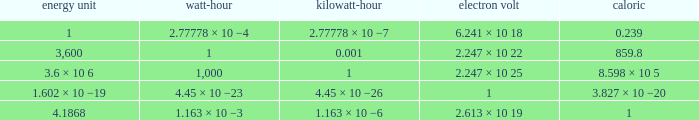Give me the full table as a dictionary. {'header': ['energy unit', 'watt-hour', 'kilowatt-hour', 'electron volt', 'caloric'], 'rows': [['1', '2.77778 × 10 −4', '2.77778 × 10 −7', '6.241 × 10 18', '0.239'], ['3,600', '1', '0.001', '2.247 × 10 22', '859.8'], ['3.6 × 10 6', '1,000', '1', '2.247 × 10 25', '8.598 × 10 5'], ['1.602 × 10 −19', '4.45 × 10 −23', '4.45 × 10 −26', '1', '3.827 × 10 −20'], ['4.1868', '1.163 × 10 −3', '1.163 × 10 −6', '2.613 × 10 19', '1']]} How many calories is 1 watt hour? 859.8. 